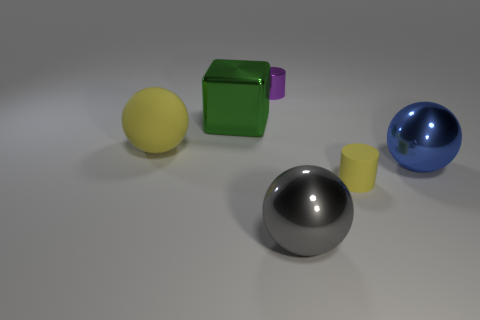Add 3 blue things. How many objects exist? 9 Subtract all cylinders. How many objects are left? 4 Subtract all brown metal cylinders. Subtract all cylinders. How many objects are left? 4 Add 4 rubber cylinders. How many rubber cylinders are left? 5 Add 2 cubes. How many cubes exist? 3 Subtract 1 yellow cylinders. How many objects are left? 5 